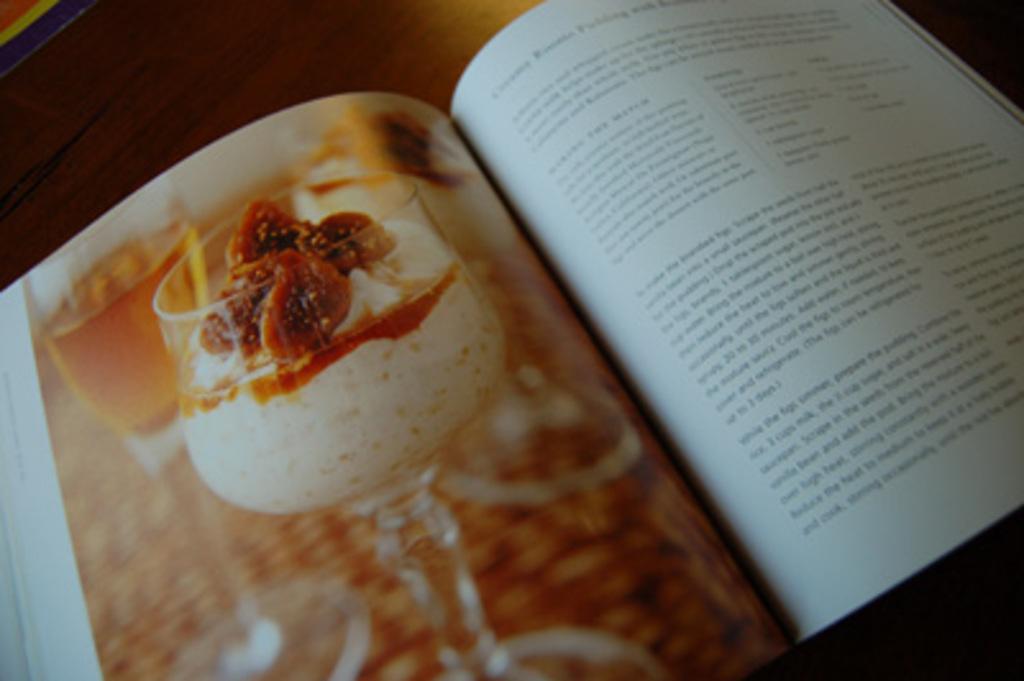Describe this image in one or two sentences. In this picture we can see book on the wooden platform, on the papers we can see glasses, ice cream and some information. 